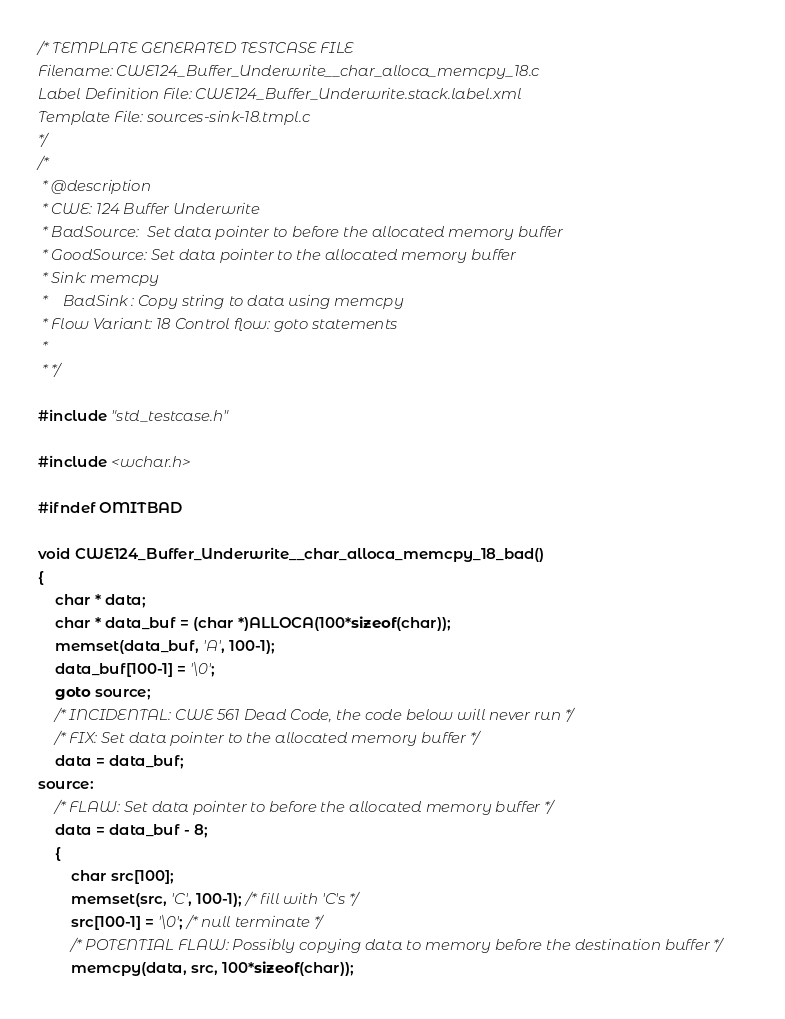<code> <loc_0><loc_0><loc_500><loc_500><_C_>/* TEMPLATE GENERATED TESTCASE FILE
Filename: CWE124_Buffer_Underwrite__char_alloca_memcpy_18.c
Label Definition File: CWE124_Buffer_Underwrite.stack.label.xml
Template File: sources-sink-18.tmpl.c
*/
/*
 * @description
 * CWE: 124 Buffer Underwrite
 * BadSource:  Set data pointer to before the allocated memory buffer
 * GoodSource: Set data pointer to the allocated memory buffer
 * Sink: memcpy
 *    BadSink : Copy string to data using memcpy
 * Flow Variant: 18 Control flow: goto statements
 *
 * */

#include "std_testcase.h"

#include <wchar.h>

#ifndef OMITBAD

void CWE124_Buffer_Underwrite__char_alloca_memcpy_18_bad()
{
    char * data;
    char * data_buf = (char *)ALLOCA(100*sizeof(char));
    memset(data_buf, 'A', 100-1);
    data_buf[100-1] = '\0';
    goto source;
    /* INCIDENTAL: CWE 561 Dead Code, the code below will never run */
    /* FIX: Set data pointer to the allocated memory buffer */
    data = data_buf;
source:
    /* FLAW: Set data pointer to before the allocated memory buffer */
    data = data_buf - 8;
    {
        char src[100];
        memset(src, 'C', 100-1); /* fill with 'C's */
        src[100-1] = '\0'; /* null terminate */
        /* POTENTIAL FLAW: Possibly copying data to memory before the destination buffer */
        memcpy(data, src, 100*sizeof(char));</code> 